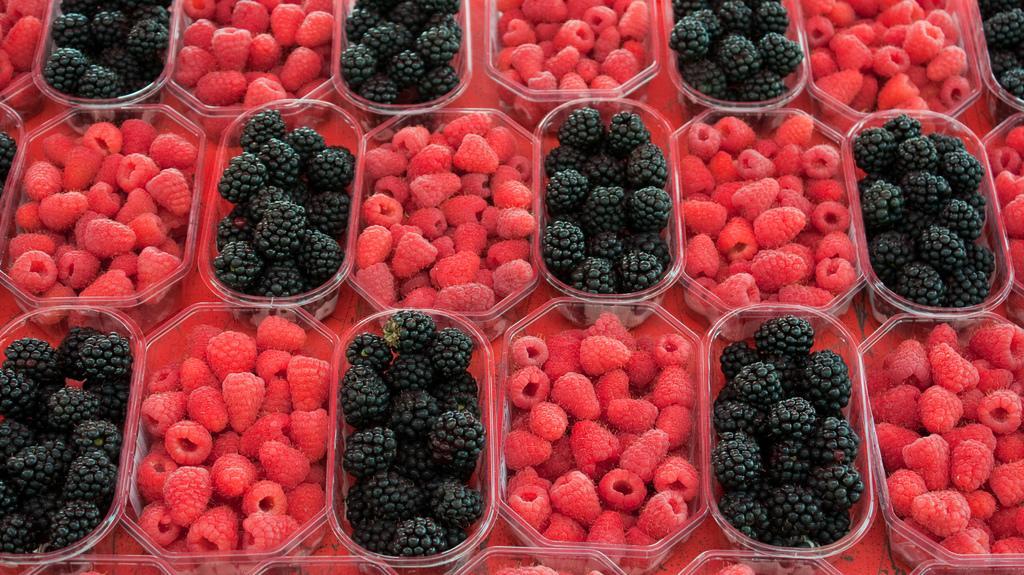How would you summarize this image in a sentence or two? This image consists of berries. They are black and red in colors which are kept in the boxes. 